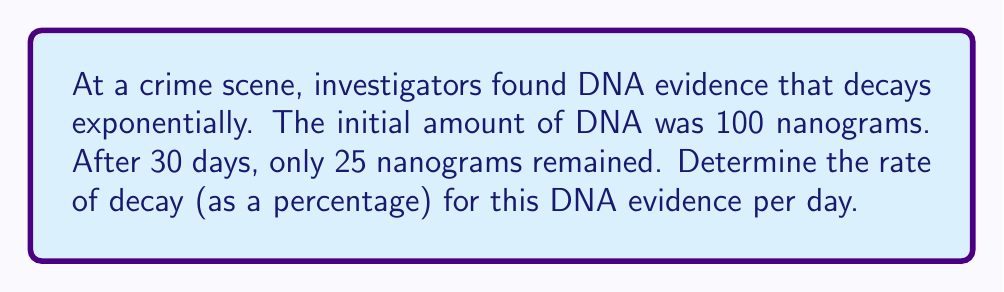Give your solution to this math problem. Let's approach this step-by-step:

1) The exponential decay formula is:
   $$A = A_0 \cdot e^{-rt}$$
   Where:
   $A$ is the final amount
   $A_0$ is the initial amount
   $r$ is the rate of decay
   $t$ is the time

2) We know:
   $A_0 = 100$ nanograms
   $A = 25$ nanograms
   $t = 30$ days

3) Let's plug these into our formula:
   $$25 = 100 \cdot e^{-r \cdot 30}$$

4) Divide both sides by 100:
   $$0.25 = e^{-30r}$$

5) Take the natural log of both sides:
   $$\ln(0.25) = -30r$$

6) Solve for $r$:
   $$r = -\frac{\ln(0.25)}{30} \approx 0.0462$$

7) This is the rate of decay per day. To convert to a percentage, multiply by 100:
   $$0.0462 \cdot 100 \approx 4.62\%$$

Therefore, the rate of decay is approximately 4.62% per day.
Answer: 4.62% per day 